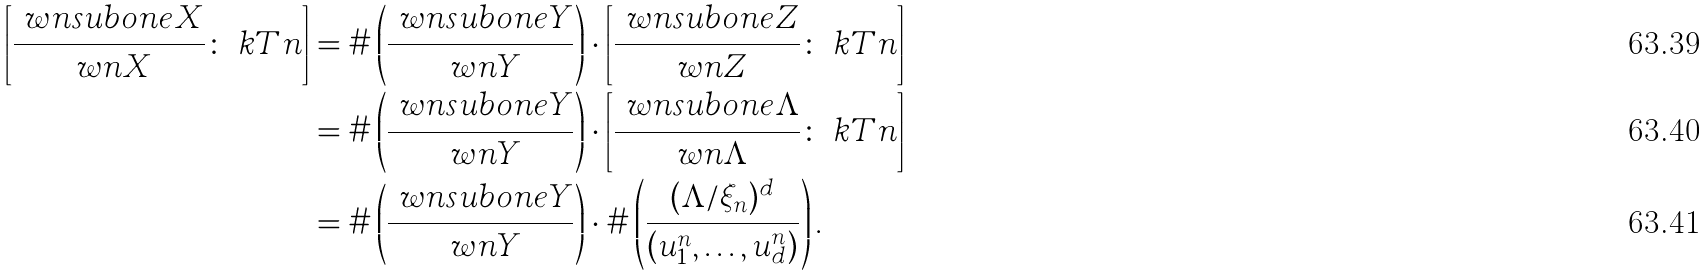<formula> <loc_0><loc_0><loc_500><loc_500>\left [ \frac { \ w n s u b o n e X } { \ w n X } \colon \ k T n \right ] & = \# \left ( \frac { \ w n s u b o n e Y } { \ w n Y } \right ) \cdot \left [ \frac { \ w n s u b o n e Z } { \ w n Z } \colon \ k T n \right ] \\ & = \# \left ( \frac { \ w n s u b o n e Y } { \ w n Y } \right ) \cdot \left [ \frac { \ w n s u b o n e \Lambda } { \ w n \Lambda } \colon \ k T n \right ] \\ & = \# \left ( \frac { \ w n s u b o n e Y } { \ w n Y } \right ) \cdot \# \left ( \frac { ( \Lambda / \xi _ { n } ) ^ { d } } { ( u ^ { n } _ { 1 } , \dots , u ^ { n } _ { d } ) } \right ) .</formula> 